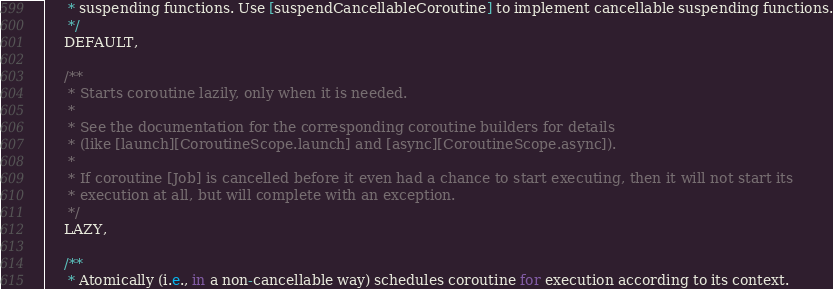<code> <loc_0><loc_0><loc_500><loc_500><_Kotlin_>     * suspending functions. Use [suspendCancellableCoroutine] to implement cancellable suspending functions.
     */
    DEFAULT,

    /**
     * Starts coroutine lazily, only when it is needed.
     *
     * See the documentation for the corresponding coroutine builders for details
     * (like [launch][CoroutineScope.launch] and [async][CoroutineScope.async]).
     *
     * If coroutine [Job] is cancelled before it even had a chance to start executing, then it will not start its
     * execution at all, but will complete with an exception.
     */
    LAZY,

    /**
     * Atomically (i.e., in a non-cancellable way) schedules coroutine for execution according to its context.</code> 